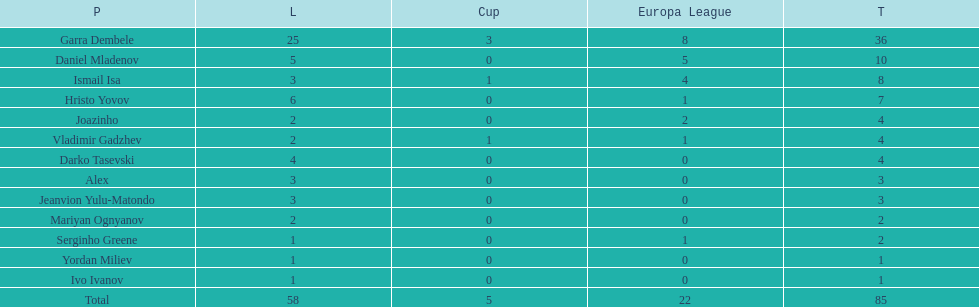Which players only scored one goal? Serginho Greene, Yordan Miliev, Ivo Ivanov. 